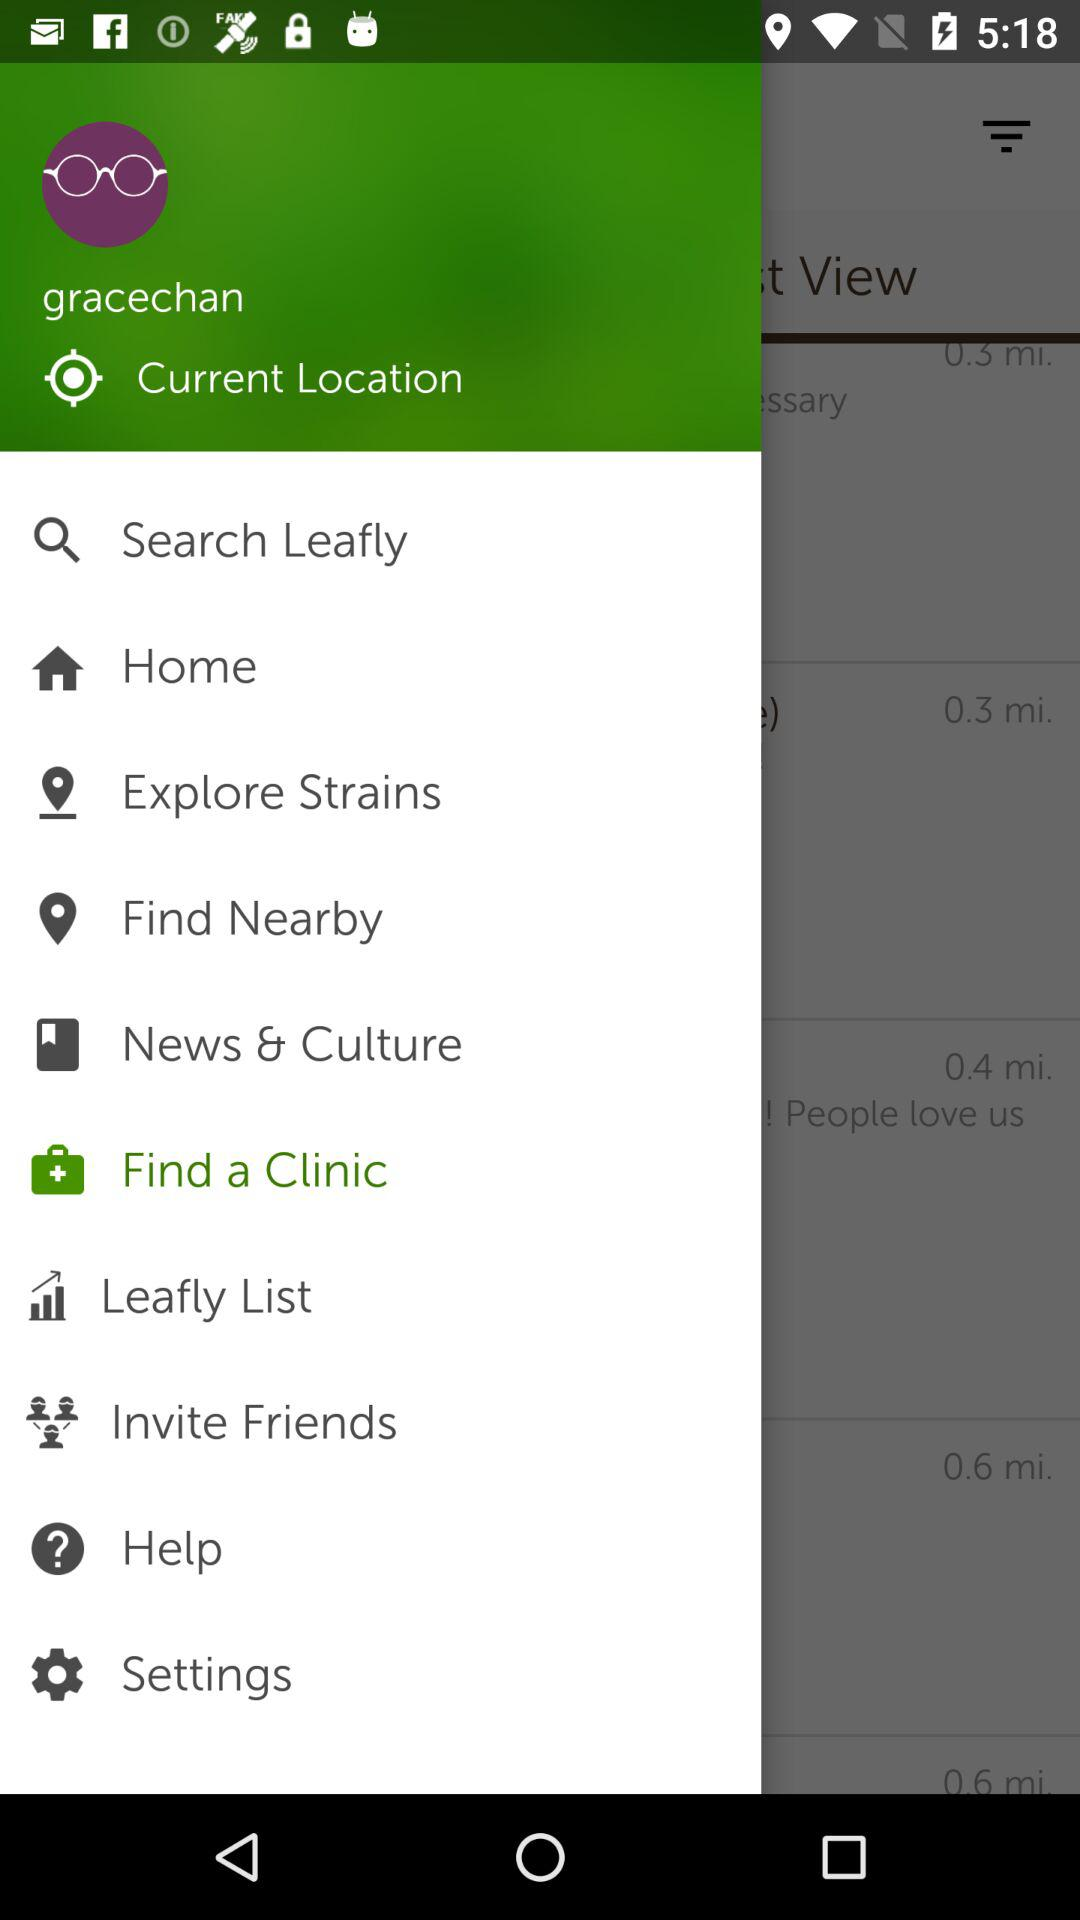What is the name of the user? The name of the user is Gracechan. 